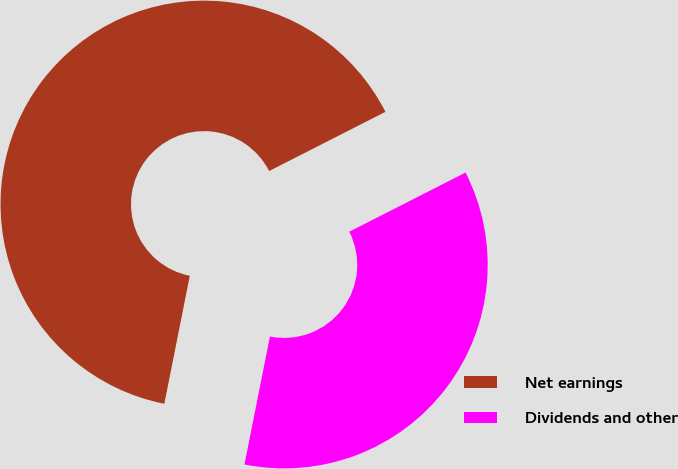Convert chart. <chart><loc_0><loc_0><loc_500><loc_500><pie_chart><fcel>Net earnings<fcel>Dividends and other<nl><fcel>64.38%<fcel>35.62%<nl></chart> 